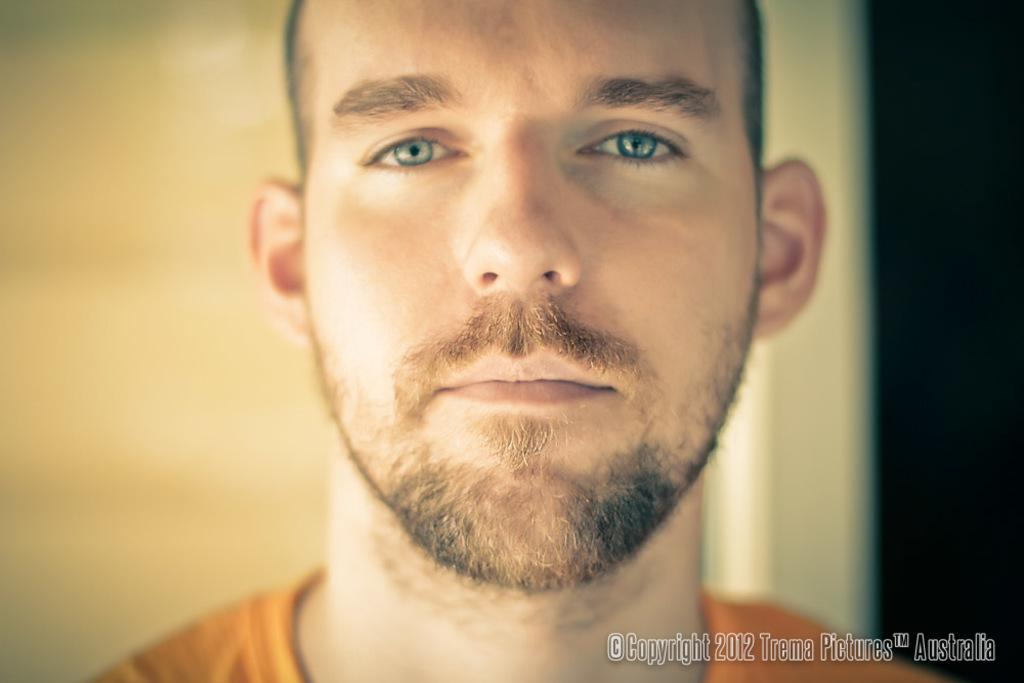What is the main subject of the image? There is a person in the image. What is the person wearing? The person is wearing an orange T-shirt. What can be seen in the background of the image? There is a wall visible in the background of the image. Is there any additional information or marking on the image? Yes, a watermark is present in the bottom right corner of the image. What type of rod is being used by the person in the image? There is no rod visible in the image; the person is wearing an orange T-shirt and standing in front of a wall. 